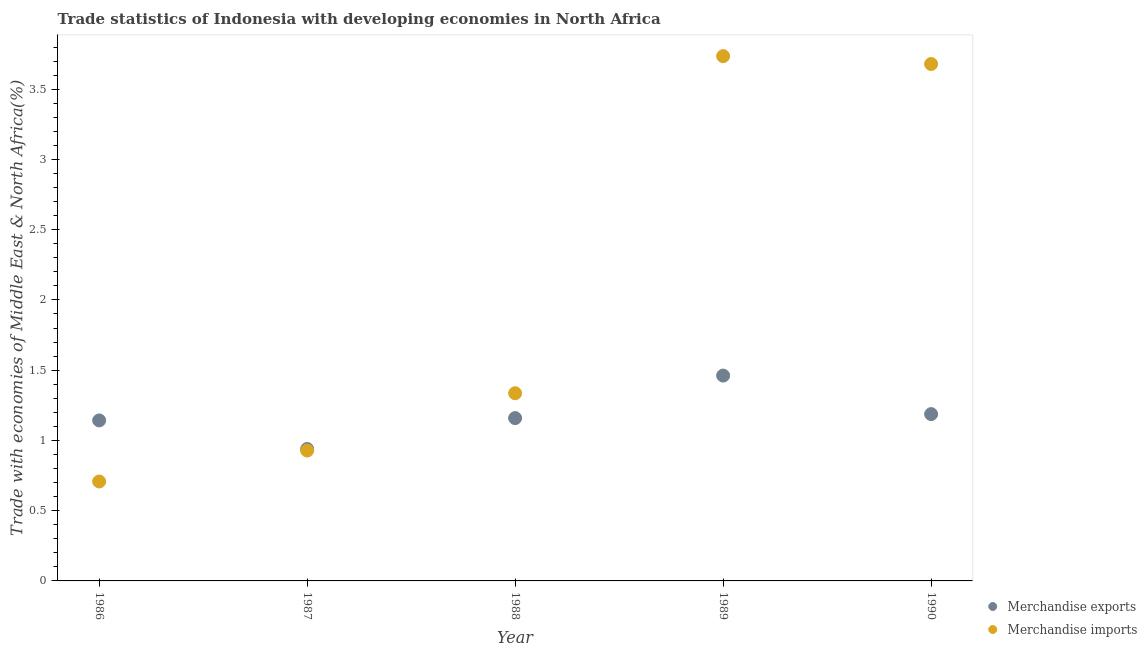Is the number of dotlines equal to the number of legend labels?
Make the answer very short. Yes. What is the merchandise exports in 1989?
Keep it short and to the point. 1.46. Across all years, what is the maximum merchandise imports?
Your answer should be very brief. 3.74. Across all years, what is the minimum merchandise exports?
Offer a terse response. 0.94. In which year was the merchandise imports maximum?
Offer a terse response. 1989. In which year was the merchandise exports minimum?
Your answer should be very brief. 1987. What is the total merchandise exports in the graph?
Offer a very short reply. 5.89. What is the difference between the merchandise imports in 1988 and that in 1990?
Provide a short and direct response. -2.34. What is the difference between the merchandise imports in 1988 and the merchandise exports in 1986?
Give a very brief answer. 0.19. What is the average merchandise imports per year?
Provide a short and direct response. 2.08. In the year 1990, what is the difference between the merchandise imports and merchandise exports?
Ensure brevity in your answer.  2.49. In how many years, is the merchandise exports greater than 2.1 %?
Give a very brief answer. 0. What is the ratio of the merchandise imports in 1989 to that in 1990?
Offer a very short reply. 1.02. Is the difference between the merchandise exports in 1989 and 1990 greater than the difference between the merchandise imports in 1989 and 1990?
Make the answer very short. Yes. What is the difference between the highest and the second highest merchandise imports?
Your response must be concise. 0.06. What is the difference between the highest and the lowest merchandise imports?
Provide a succinct answer. 3.03. Is the sum of the merchandise imports in 1989 and 1990 greater than the maximum merchandise exports across all years?
Keep it short and to the point. Yes. Is the merchandise exports strictly greater than the merchandise imports over the years?
Ensure brevity in your answer.  No. What is the difference between two consecutive major ticks on the Y-axis?
Provide a short and direct response. 0.5. Does the graph contain grids?
Make the answer very short. No. How are the legend labels stacked?
Your answer should be very brief. Vertical. What is the title of the graph?
Your response must be concise. Trade statistics of Indonesia with developing economies in North Africa. Does "Central government" appear as one of the legend labels in the graph?
Your answer should be very brief. No. What is the label or title of the X-axis?
Offer a terse response. Year. What is the label or title of the Y-axis?
Offer a terse response. Trade with economies of Middle East & North Africa(%). What is the Trade with economies of Middle East & North Africa(%) in Merchandise exports in 1986?
Keep it short and to the point. 1.14. What is the Trade with economies of Middle East & North Africa(%) in Merchandise imports in 1986?
Your answer should be very brief. 0.71. What is the Trade with economies of Middle East & North Africa(%) of Merchandise exports in 1987?
Your answer should be compact. 0.94. What is the Trade with economies of Middle East & North Africa(%) in Merchandise imports in 1987?
Provide a short and direct response. 0.93. What is the Trade with economies of Middle East & North Africa(%) in Merchandise exports in 1988?
Provide a short and direct response. 1.16. What is the Trade with economies of Middle East & North Africa(%) in Merchandise imports in 1988?
Offer a very short reply. 1.34. What is the Trade with economies of Middle East & North Africa(%) in Merchandise exports in 1989?
Offer a very short reply. 1.46. What is the Trade with economies of Middle East & North Africa(%) in Merchandise imports in 1989?
Your answer should be compact. 3.74. What is the Trade with economies of Middle East & North Africa(%) in Merchandise exports in 1990?
Offer a terse response. 1.19. What is the Trade with economies of Middle East & North Africa(%) in Merchandise imports in 1990?
Make the answer very short. 3.68. Across all years, what is the maximum Trade with economies of Middle East & North Africa(%) in Merchandise exports?
Make the answer very short. 1.46. Across all years, what is the maximum Trade with economies of Middle East & North Africa(%) of Merchandise imports?
Your answer should be very brief. 3.74. Across all years, what is the minimum Trade with economies of Middle East & North Africa(%) of Merchandise exports?
Offer a very short reply. 0.94. Across all years, what is the minimum Trade with economies of Middle East & North Africa(%) of Merchandise imports?
Ensure brevity in your answer.  0.71. What is the total Trade with economies of Middle East & North Africa(%) in Merchandise exports in the graph?
Offer a very short reply. 5.89. What is the total Trade with economies of Middle East & North Africa(%) in Merchandise imports in the graph?
Keep it short and to the point. 10.39. What is the difference between the Trade with economies of Middle East & North Africa(%) in Merchandise exports in 1986 and that in 1987?
Ensure brevity in your answer.  0.2. What is the difference between the Trade with economies of Middle East & North Africa(%) of Merchandise imports in 1986 and that in 1987?
Your answer should be very brief. -0.22. What is the difference between the Trade with economies of Middle East & North Africa(%) in Merchandise exports in 1986 and that in 1988?
Offer a very short reply. -0.02. What is the difference between the Trade with economies of Middle East & North Africa(%) in Merchandise imports in 1986 and that in 1988?
Offer a very short reply. -0.63. What is the difference between the Trade with economies of Middle East & North Africa(%) of Merchandise exports in 1986 and that in 1989?
Keep it short and to the point. -0.32. What is the difference between the Trade with economies of Middle East & North Africa(%) in Merchandise imports in 1986 and that in 1989?
Your answer should be compact. -3.03. What is the difference between the Trade with economies of Middle East & North Africa(%) of Merchandise exports in 1986 and that in 1990?
Your answer should be very brief. -0.04. What is the difference between the Trade with economies of Middle East & North Africa(%) in Merchandise imports in 1986 and that in 1990?
Make the answer very short. -2.97. What is the difference between the Trade with economies of Middle East & North Africa(%) in Merchandise exports in 1987 and that in 1988?
Provide a succinct answer. -0.22. What is the difference between the Trade with economies of Middle East & North Africa(%) of Merchandise imports in 1987 and that in 1988?
Your answer should be compact. -0.41. What is the difference between the Trade with economies of Middle East & North Africa(%) in Merchandise exports in 1987 and that in 1989?
Ensure brevity in your answer.  -0.52. What is the difference between the Trade with economies of Middle East & North Africa(%) in Merchandise imports in 1987 and that in 1989?
Offer a terse response. -2.81. What is the difference between the Trade with economies of Middle East & North Africa(%) of Merchandise exports in 1987 and that in 1990?
Your answer should be compact. -0.25. What is the difference between the Trade with economies of Middle East & North Africa(%) in Merchandise imports in 1987 and that in 1990?
Your answer should be very brief. -2.75. What is the difference between the Trade with economies of Middle East & North Africa(%) of Merchandise exports in 1988 and that in 1989?
Your response must be concise. -0.3. What is the difference between the Trade with economies of Middle East & North Africa(%) in Merchandise imports in 1988 and that in 1989?
Offer a terse response. -2.4. What is the difference between the Trade with economies of Middle East & North Africa(%) in Merchandise exports in 1988 and that in 1990?
Provide a short and direct response. -0.03. What is the difference between the Trade with economies of Middle East & North Africa(%) of Merchandise imports in 1988 and that in 1990?
Offer a terse response. -2.34. What is the difference between the Trade with economies of Middle East & North Africa(%) in Merchandise exports in 1989 and that in 1990?
Your answer should be compact. 0.27. What is the difference between the Trade with economies of Middle East & North Africa(%) in Merchandise imports in 1989 and that in 1990?
Keep it short and to the point. 0.06. What is the difference between the Trade with economies of Middle East & North Africa(%) in Merchandise exports in 1986 and the Trade with economies of Middle East & North Africa(%) in Merchandise imports in 1987?
Give a very brief answer. 0.21. What is the difference between the Trade with economies of Middle East & North Africa(%) of Merchandise exports in 1986 and the Trade with economies of Middle East & North Africa(%) of Merchandise imports in 1988?
Offer a terse response. -0.19. What is the difference between the Trade with economies of Middle East & North Africa(%) in Merchandise exports in 1986 and the Trade with economies of Middle East & North Africa(%) in Merchandise imports in 1989?
Offer a very short reply. -2.59. What is the difference between the Trade with economies of Middle East & North Africa(%) in Merchandise exports in 1986 and the Trade with economies of Middle East & North Africa(%) in Merchandise imports in 1990?
Your answer should be compact. -2.54. What is the difference between the Trade with economies of Middle East & North Africa(%) of Merchandise exports in 1987 and the Trade with economies of Middle East & North Africa(%) of Merchandise imports in 1988?
Provide a succinct answer. -0.4. What is the difference between the Trade with economies of Middle East & North Africa(%) in Merchandise exports in 1987 and the Trade with economies of Middle East & North Africa(%) in Merchandise imports in 1989?
Provide a succinct answer. -2.8. What is the difference between the Trade with economies of Middle East & North Africa(%) in Merchandise exports in 1987 and the Trade with economies of Middle East & North Africa(%) in Merchandise imports in 1990?
Ensure brevity in your answer.  -2.74. What is the difference between the Trade with economies of Middle East & North Africa(%) in Merchandise exports in 1988 and the Trade with economies of Middle East & North Africa(%) in Merchandise imports in 1989?
Provide a succinct answer. -2.58. What is the difference between the Trade with economies of Middle East & North Africa(%) of Merchandise exports in 1988 and the Trade with economies of Middle East & North Africa(%) of Merchandise imports in 1990?
Give a very brief answer. -2.52. What is the difference between the Trade with economies of Middle East & North Africa(%) in Merchandise exports in 1989 and the Trade with economies of Middle East & North Africa(%) in Merchandise imports in 1990?
Give a very brief answer. -2.22. What is the average Trade with economies of Middle East & North Africa(%) in Merchandise exports per year?
Provide a succinct answer. 1.18. What is the average Trade with economies of Middle East & North Africa(%) of Merchandise imports per year?
Give a very brief answer. 2.08. In the year 1986, what is the difference between the Trade with economies of Middle East & North Africa(%) in Merchandise exports and Trade with economies of Middle East & North Africa(%) in Merchandise imports?
Offer a very short reply. 0.43. In the year 1987, what is the difference between the Trade with economies of Middle East & North Africa(%) in Merchandise exports and Trade with economies of Middle East & North Africa(%) in Merchandise imports?
Give a very brief answer. 0.01. In the year 1988, what is the difference between the Trade with economies of Middle East & North Africa(%) of Merchandise exports and Trade with economies of Middle East & North Africa(%) of Merchandise imports?
Offer a very short reply. -0.18. In the year 1989, what is the difference between the Trade with economies of Middle East & North Africa(%) of Merchandise exports and Trade with economies of Middle East & North Africa(%) of Merchandise imports?
Keep it short and to the point. -2.27. In the year 1990, what is the difference between the Trade with economies of Middle East & North Africa(%) of Merchandise exports and Trade with economies of Middle East & North Africa(%) of Merchandise imports?
Your response must be concise. -2.49. What is the ratio of the Trade with economies of Middle East & North Africa(%) of Merchandise exports in 1986 to that in 1987?
Offer a terse response. 1.22. What is the ratio of the Trade with economies of Middle East & North Africa(%) in Merchandise imports in 1986 to that in 1987?
Keep it short and to the point. 0.76. What is the ratio of the Trade with economies of Middle East & North Africa(%) of Merchandise exports in 1986 to that in 1988?
Keep it short and to the point. 0.99. What is the ratio of the Trade with economies of Middle East & North Africa(%) in Merchandise imports in 1986 to that in 1988?
Your response must be concise. 0.53. What is the ratio of the Trade with economies of Middle East & North Africa(%) in Merchandise exports in 1986 to that in 1989?
Your answer should be very brief. 0.78. What is the ratio of the Trade with economies of Middle East & North Africa(%) of Merchandise imports in 1986 to that in 1989?
Your answer should be very brief. 0.19. What is the ratio of the Trade with economies of Middle East & North Africa(%) in Merchandise exports in 1986 to that in 1990?
Your answer should be very brief. 0.96. What is the ratio of the Trade with economies of Middle East & North Africa(%) in Merchandise imports in 1986 to that in 1990?
Offer a terse response. 0.19. What is the ratio of the Trade with economies of Middle East & North Africa(%) of Merchandise exports in 1987 to that in 1988?
Provide a succinct answer. 0.81. What is the ratio of the Trade with economies of Middle East & North Africa(%) in Merchandise imports in 1987 to that in 1988?
Offer a terse response. 0.69. What is the ratio of the Trade with economies of Middle East & North Africa(%) of Merchandise exports in 1987 to that in 1989?
Provide a short and direct response. 0.64. What is the ratio of the Trade with economies of Middle East & North Africa(%) in Merchandise imports in 1987 to that in 1989?
Make the answer very short. 0.25. What is the ratio of the Trade with economies of Middle East & North Africa(%) of Merchandise exports in 1987 to that in 1990?
Offer a very short reply. 0.79. What is the ratio of the Trade with economies of Middle East & North Africa(%) in Merchandise imports in 1987 to that in 1990?
Your response must be concise. 0.25. What is the ratio of the Trade with economies of Middle East & North Africa(%) in Merchandise exports in 1988 to that in 1989?
Provide a short and direct response. 0.79. What is the ratio of the Trade with economies of Middle East & North Africa(%) of Merchandise imports in 1988 to that in 1989?
Your answer should be compact. 0.36. What is the ratio of the Trade with economies of Middle East & North Africa(%) in Merchandise exports in 1988 to that in 1990?
Your answer should be compact. 0.98. What is the ratio of the Trade with economies of Middle East & North Africa(%) in Merchandise imports in 1988 to that in 1990?
Provide a short and direct response. 0.36. What is the ratio of the Trade with economies of Middle East & North Africa(%) of Merchandise exports in 1989 to that in 1990?
Your response must be concise. 1.23. What is the ratio of the Trade with economies of Middle East & North Africa(%) of Merchandise imports in 1989 to that in 1990?
Offer a very short reply. 1.02. What is the difference between the highest and the second highest Trade with economies of Middle East & North Africa(%) in Merchandise exports?
Give a very brief answer. 0.27. What is the difference between the highest and the second highest Trade with economies of Middle East & North Africa(%) in Merchandise imports?
Provide a succinct answer. 0.06. What is the difference between the highest and the lowest Trade with economies of Middle East & North Africa(%) in Merchandise exports?
Offer a very short reply. 0.52. What is the difference between the highest and the lowest Trade with economies of Middle East & North Africa(%) of Merchandise imports?
Your answer should be compact. 3.03. 